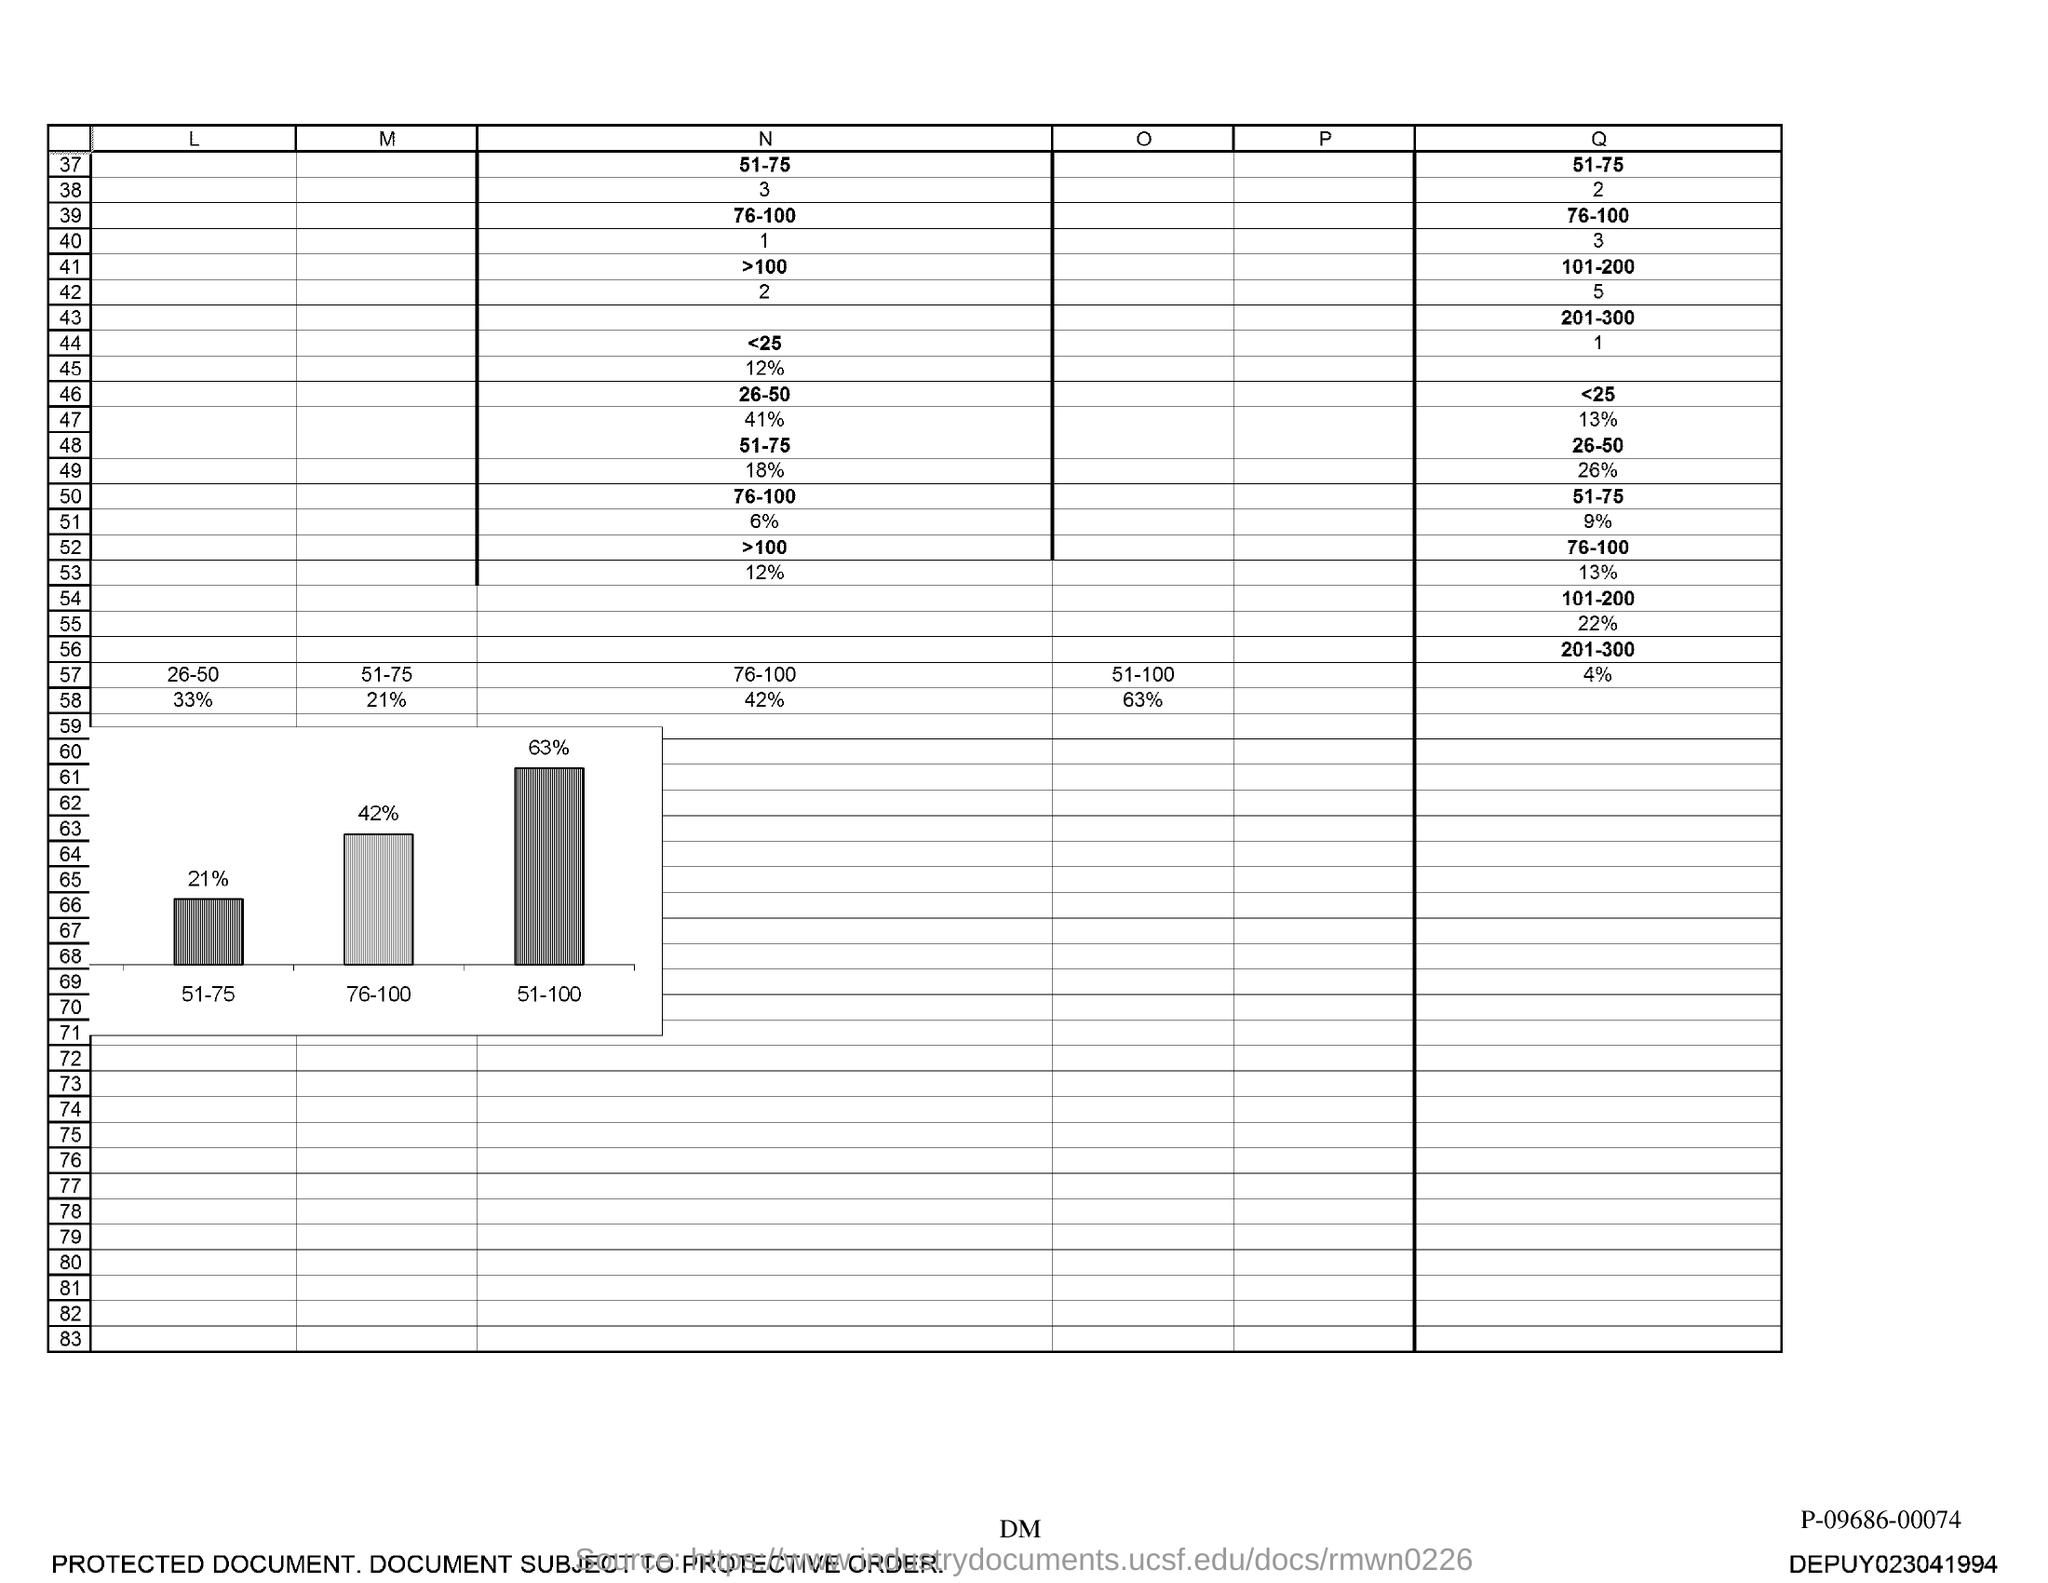The range of N associated with the number 37?
Ensure brevity in your answer.  51-75. 